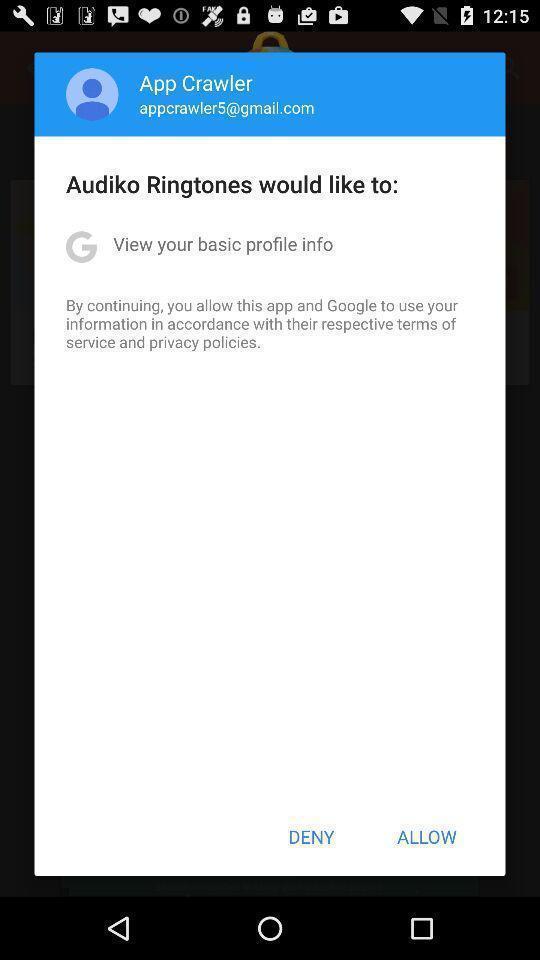What is the overall content of this screenshot? Screen displaying the pop up of allow notification. 